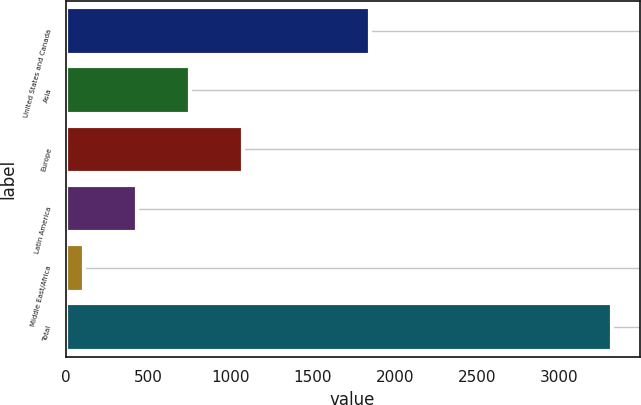Convert chart. <chart><loc_0><loc_0><loc_500><loc_500><bar_chart><fcel>United States and Canada<fcel>Asia<fcel>Europe<fcel>Latin America<fcel>Middle East/Africa<fcel>Total<nl><fcel>1852<fcel>756.2<fcel>1076.8<fcel>435.6<fcel>115<fcel>3321<nl></chart> 